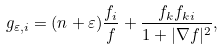Convert formula to latex. <formula><loc_0><loc_0><loc_500><loc_500>g _ { \varepsilon , i } = ( n + \varepsilon ) \frac { f _ { i } } { f } + \frac { f _ { k } f _ { k i } } { 1 + | \nabla f | ^ { 2 } } ,</formula> 